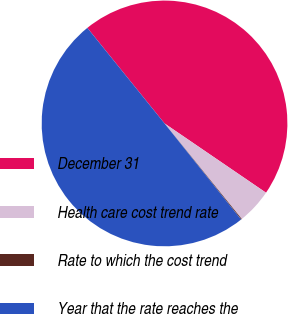<chart> <loc_0><loc_0><loc_500><loc_500><pie_chart><fcel>December 31<fcel>Health care cost trend rate<fcel>Rate to which the cost trend<fcel>Year that the rate reaches the<nl><fcel>45.35%<fcel>4.65%<fcel>0.11%<fcel>49.89%<nl></chart> 